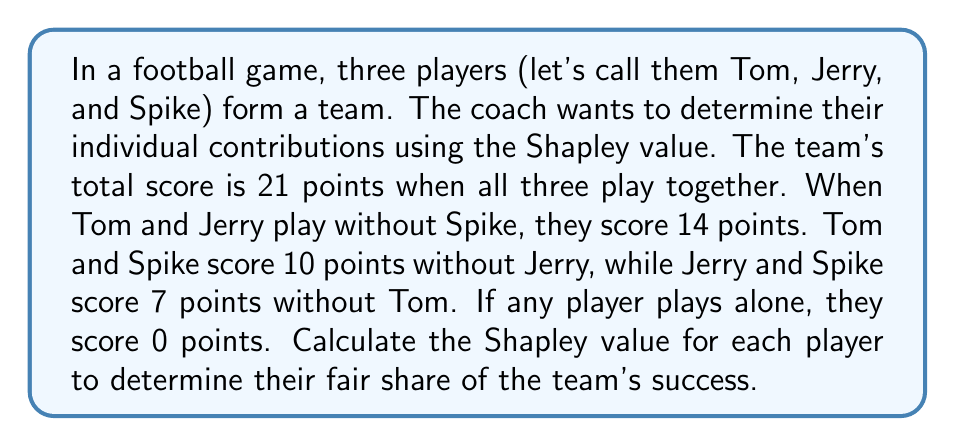Help me with this question. To calculate the Shapley value, we need to consider all possible coalitions and the marginal contributions of each player. Let's go through this step-by-step:

1. List all possible coalitions:
   $\{\}, \{T\}, \{J\}, \{S\}, \{T,J\}, \{T,S\}, \{J,S\}, \{T,J,S\}$

2. Calculate the value function $v$ for each coalition:
   $v(\{\}) = 0$
   $v(\{T\}) = v(\{J\}) = v(\{S\}) = 0$
   $v(\{T,J\}) = 14$
   $v(\{T,S\}) = 10$
   $v(\{J,S\}) = 7$
   $v(\{T,J,S\}) = 21$

3. Calculate marginal contributions for each player in each ordering:
   
   For Tom (T):
   TJS: 0 - 0 = 0
   TJA: 14 - 0 = 14
   JST: 21 - 7 = 14
   JST: 21 - 7 = 14
   STJ: 10 - 0 = 10
   SJT: 21 - 7 = 14

   For Jerry (J):
   JTS: 0 - 0 = 0
   JTA: 14 - 0 = 14
   TJS: 14 - 0 = 14
   TSJ: 21 - 10 = 11
   SJT: 7 - 0 = 7
   STJ: 21 - 10 = 11

   For Spike (S):
   STJ: 0 - 0 = 0
   SJT: 7 - 0 = 7
   TSJ: 10 - 0 = 10
   TJS: 21 - 14 = 7
   JST: 7 - 0 = 7
   JTS: 21 - 14 = 7

4. Calculate the average of marginal contributions for each player:

   Tom: $\phi_T = \frac{0 + 14 + 14 + 14 + 10 + 14}{6} = 11$

   Jerry: $\phi_J = \frac{0 + 14 + 14 + 11 + 7 + 11}{6} = 9.5$

   Spike: $\phi_S = \frac{0 + 7 + 10 + 7 + 7 + 7}{6} = 6.33$ (rounded to 2 decimal places)

These values represent the Shapley values for each player, indicating their fair share of the team's success based on their marginal contributions.
Answer: The Shapley values for the players are:
Tom: 11 points
Jerry: 9.5 points
Spike: 6.33 points (rounded to 2 decimal places) 